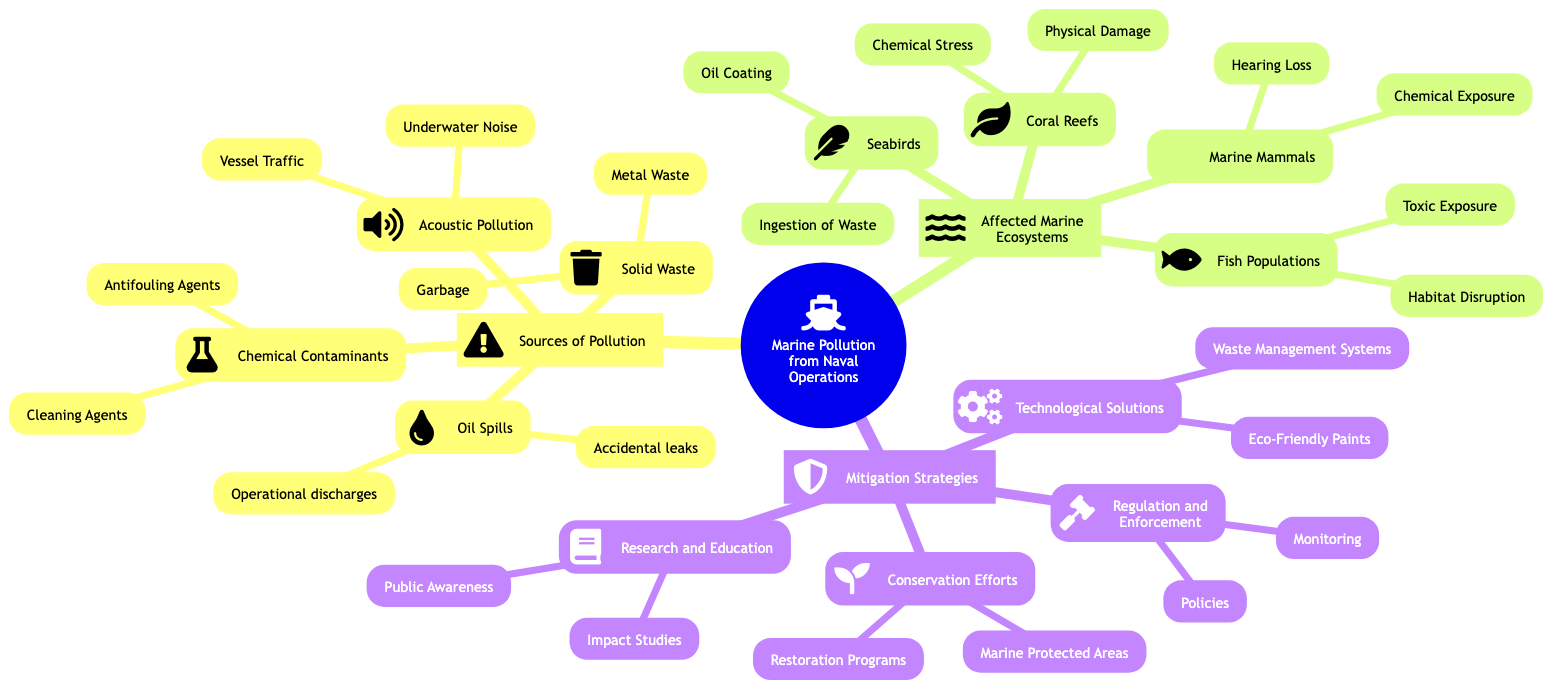What are the two main categories of pollution sources in naval operations? The diagram lists "Sources of Pollution" as a primary category, which contains two main subcategories: "Oil Spills" and "Chemical Contaminants."
Answer: Oil Spills, Chemical Contaminants How many types of marine ecosystems are affected by naval operations? In the "Affected Marine Ecosystems" section, there are four distinct types listed: "Coral Reefs," "Marine Mammals," "Fish Populations," and "Seabirds." Counting these gives a total of four.
Answer: 4 What is one example of a solid waste type from naval operations? The diagram specifies "Solid Waste" as a category, with "Garbage" and "Metal Waste" listed as examples. Thus, one example from this section would be "Garbage."
Answer: Garbage Which marine ecosystem is affected by chemical exposure? Under "Marine Mammals," the diagram explicitly states that this ecosystem faces "Chemical Exposure," indicating the relevance of chemical contamination to this group.
Answer: Marine Mammals What are the two mitigation strategies subcategories related to technological solutions? The diagram describes "Technological Solutions" under "Mitigation Strategies," which lists "Waste Management Systems" and "Eco-Friendly Paints" as the two specific subcategories pertinent to this strategy.
Answer: Waste Management Systems, Eco-Friendly Paints What kind of pollution is described by "Sonar interference"? In the "Marine Mammals" section, the issue of "Hearing Loss" is attributed to "Sonar interference," showcasing how acoustic pollution impacts this marine group.
Answer: Hearing Loss How many distinct sources of oil spills are identified in the diagram? Under "Oil Spills," there are two specific types listed: "Accidental leaks" and "Operational discharges," thus totaling two distinct sources of oil spills.
Answer: 2 What is one conservation effort mentioned in the diagram? The diagram presents "Conservation Efforts" in the "Mitigation Strategies" category, with "Marine Protected Areas" listed as one specific effort aimed at conservation.
Answer: Marine Protected Areas 